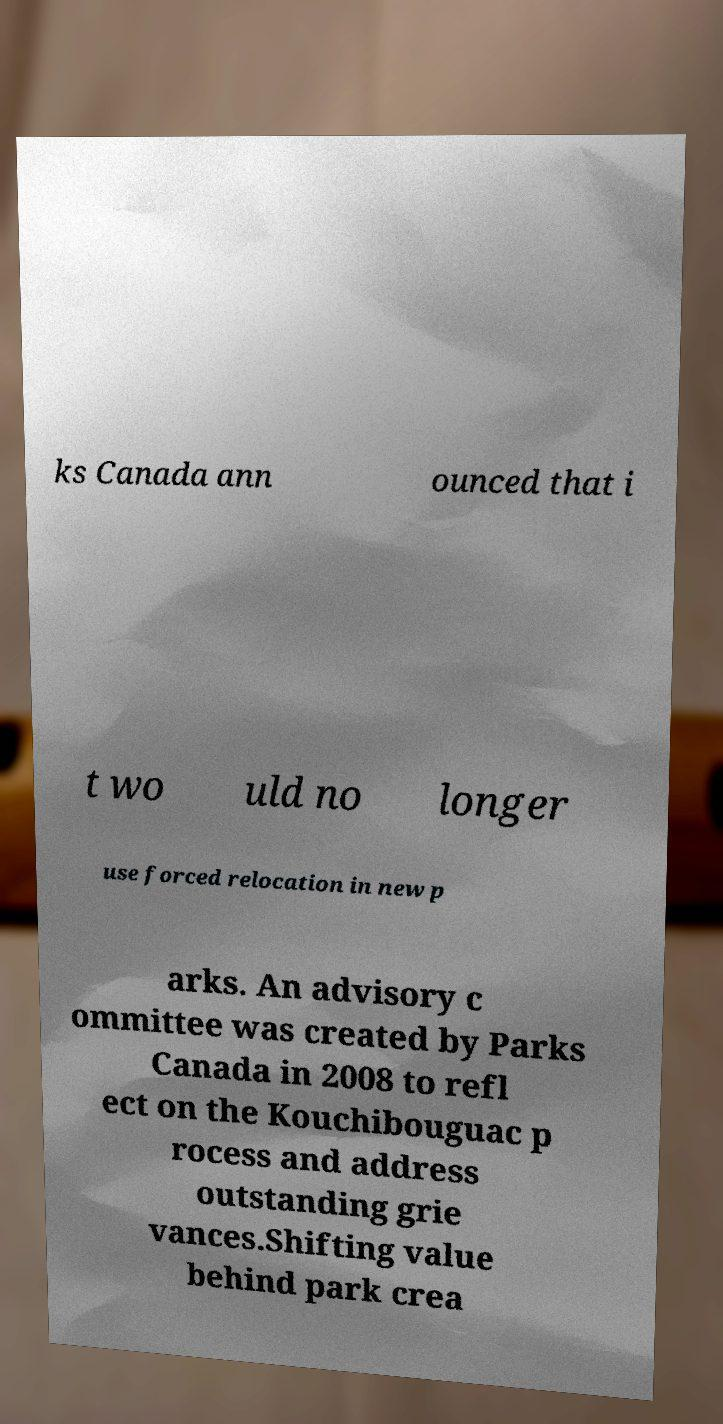I need the written content from this picture converted into text. Can you do that? ks Canada ann ounced that i t wo uld no longer use forced relocation in new p arks. An advisory c ommittee was created by Parks Canada in 2008 to refl ect on the Kouchibouguac p rocess and address outstanding grie vances.Shifting value behind park crea 